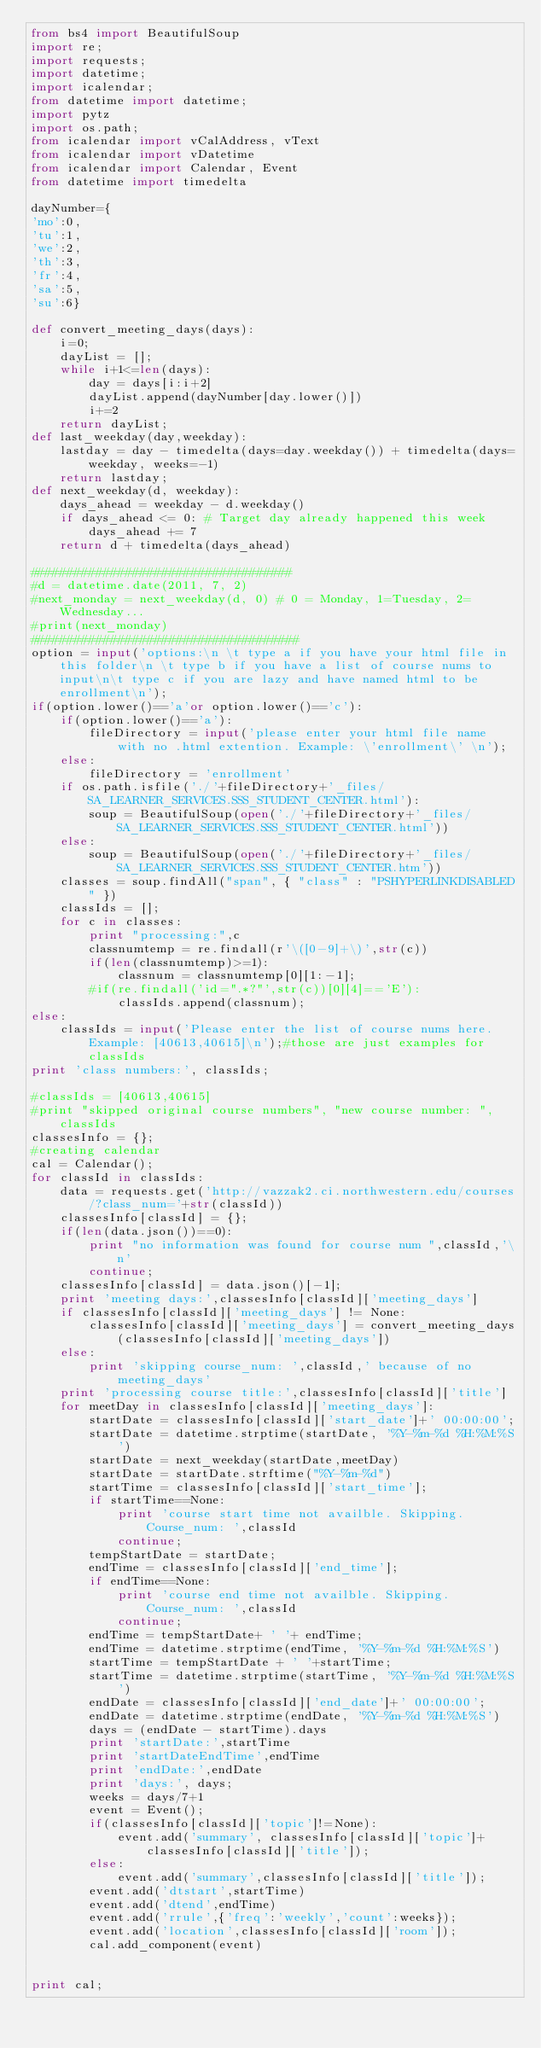<code> <loc_0><loc_0><loc_500><loc_500><_Python_>from bs4 import BeautifulSoup
import re;
import requests;
import datetime;
import icalendar;
from datetime import datetime;
import pytz
import os.path;
from icalendar import vCalAddress, vText
from icalendar import vDatetime
from icalendar import Calendar, Event
from datetime import timedelta

dayNumber={
'mo':0,
'tu':1,
'we':2,
'th':3,
'fr':4,
'sa':5,
'su':6}

def convert_meeting_days(days):
    i=0;
    dayList = [];
    while i+1<=len(days):
        day = days[i:i+2]
        dayList.append(dayNumber[day.lower()])
        i+=2
    return dayList;
def last_weekday(day,weekday):
    lastday = day - timedelta(days=day.weekday()) + timedelta(days=weekday, weeks=-1)
    return lastday;
def next_weekday(d, weekday):
    days_ahead = weekday - d.weekday()
    if days_ahead <= 0: # Target day already happened this week
        days_ahead += 7
    return d + timedelta(days_ahead)

####################################
#d = datetime.date(2011, 7, 2)
#next_monday = next_weekday(d, 0) # 0 = Monday, 1=Tuesday, 2=Wednesday...
#print(next_monday)
#####################################
option = input('options:\n \t type a if you have your html file in this folder\n \t type b if you have a list of course nums to input\n\t type c if you are lazy and have named html to be enrollment\n');
if(option.lower()=='a'or option.lower()=='c'):
    if(option.lower()=='a'):
        fileDirectory = input('please enter your html file name with no .html extention. Example: \'enrollment\' \n');
    else:
        fileDirectory = 'enrollment'
    if os.path.isfile('./'+fileDirectory+'_files/SA_LEARNER_SERVICES.SSS_STUDENT_CENTER.html'):
        soup = BeautifulSoup(open('./'+fileDirectory+'_files/SA_LEARNER_SERVICES.SSS_STUDENT_CENTER.html'))
    else:
        soup = BeautifulSoup(open('./'+fileDirectory+'_files/SA_LEARNER_SERVICES.SSS_STUDENT_CENTER.htm'))
    classes = soup.findAll("span", { "class" : "PSHYPERLINKDISABLED" })
    classIds = [];
    for c in classes:
        print "processing:",c
        classnumtemp = re.findall(r'\([0-9]+\)',str(c))
        if(len(classnumtemp)>=1):
            classnum = classnumtemp[0][1:-1];
        #if(re.findall('id=".*?"',str(c))[0][4]=='E'):
            classIds.append(classnum);
else:
    classIds = input('Please enter the list of course nums here. Example: [40613,40615]\n');#those are just examples for classIds
print 'class numbers:', classIds;

#classIds = [40613,40615]
#print "skipped original course numbers", "new course number: ",classIds
classesInfo = {};
#creating calendar
cal = Calendar();
for classId in classIds:
    data = requests.get('http://vazzak2.ci.northwestern.edu/courses/?class_num='+str(classId))
    classesInfo[classId] = {};
    if(len(data.json())==0):
        print "no information was found for course num ",classId,'\n'
        continue;
    classesInfo[classId] = data.json()[-1];
    print 'meeting days:',classesInfo[classId]['meeting_days']
    if classesInfo[classId]['meeting_days'] != None:
        classesInfo[classId]['meeting_days'] = convert_meeting_days(classesInfo[classId]['meeting_days'])
    else:
        print 'skipping course_num: ',classId,' because of no meeting_days'
    print 'processing course title:',classesInfo[classId]['title']
    for meetDay in classesInfo[classId]['meeting_days']:
        startDate = classesInfo[classId]['start_date']+' 00:00:00';
        startDate = datetime.strptime(startDate, '%Y-%m-%d %H:%M:%S')
        startDate = next_weekday(startDate,meetDay) 
        startDate = startDate.strftime("%Y-%m-%d") 
        startTime = classesInfo[classId]['start_time'];
        if startTime==None:
            print 'course start time not availble. Skipping. Course_num: ',classId
            continue;
        tempStartDate = startDate;
        endTime = classesInfo[classId]['end_time'];
        if endTime==None:
            print 'course end time not availble. Skipping. Course_num: ',classId
            continue;
        endTime = tempStartDate+ ' '+ endTime;
        endTime = datetime.strptime(endTime, '%Y-%m-%d %H:%M:%S')
        startTime = tempStartDate + ' '+startTime;
        startTime = datetime.strptime(startTime, '%Y-%m-%d %H:%M:%S')
        endDate = classesInfo[classId]['end_date']+' 00:00:00';
        endDate = datetime.strptime(endDate, '%Y-%m-%d %H:%M:%S')
        days = (endDate - startTime).days
        print 'startDate:',startTime
        print 'startDateEndTime',endTime
        print 'endDate:',endDate
        print 'days:', days;
        weeks = days/7+1  
        event = Event();
        if(classesInfo[classId]['topic']!=None):
            event.add('summary', classesInfo[classId]['topic']+classesInfo[classId]['title']);
        else:
            event.add('summary',classesInfo[classId]['title']);
        event.add('dtstart',startTime)
        event.add('dtend',endTime)
        event.add('rrule',{'freq':'weekly','count':weeks});
        event.add('location',classesInfo[classId]['room']);
        cal.add_component(event)
        
        
print cal;        </code> 